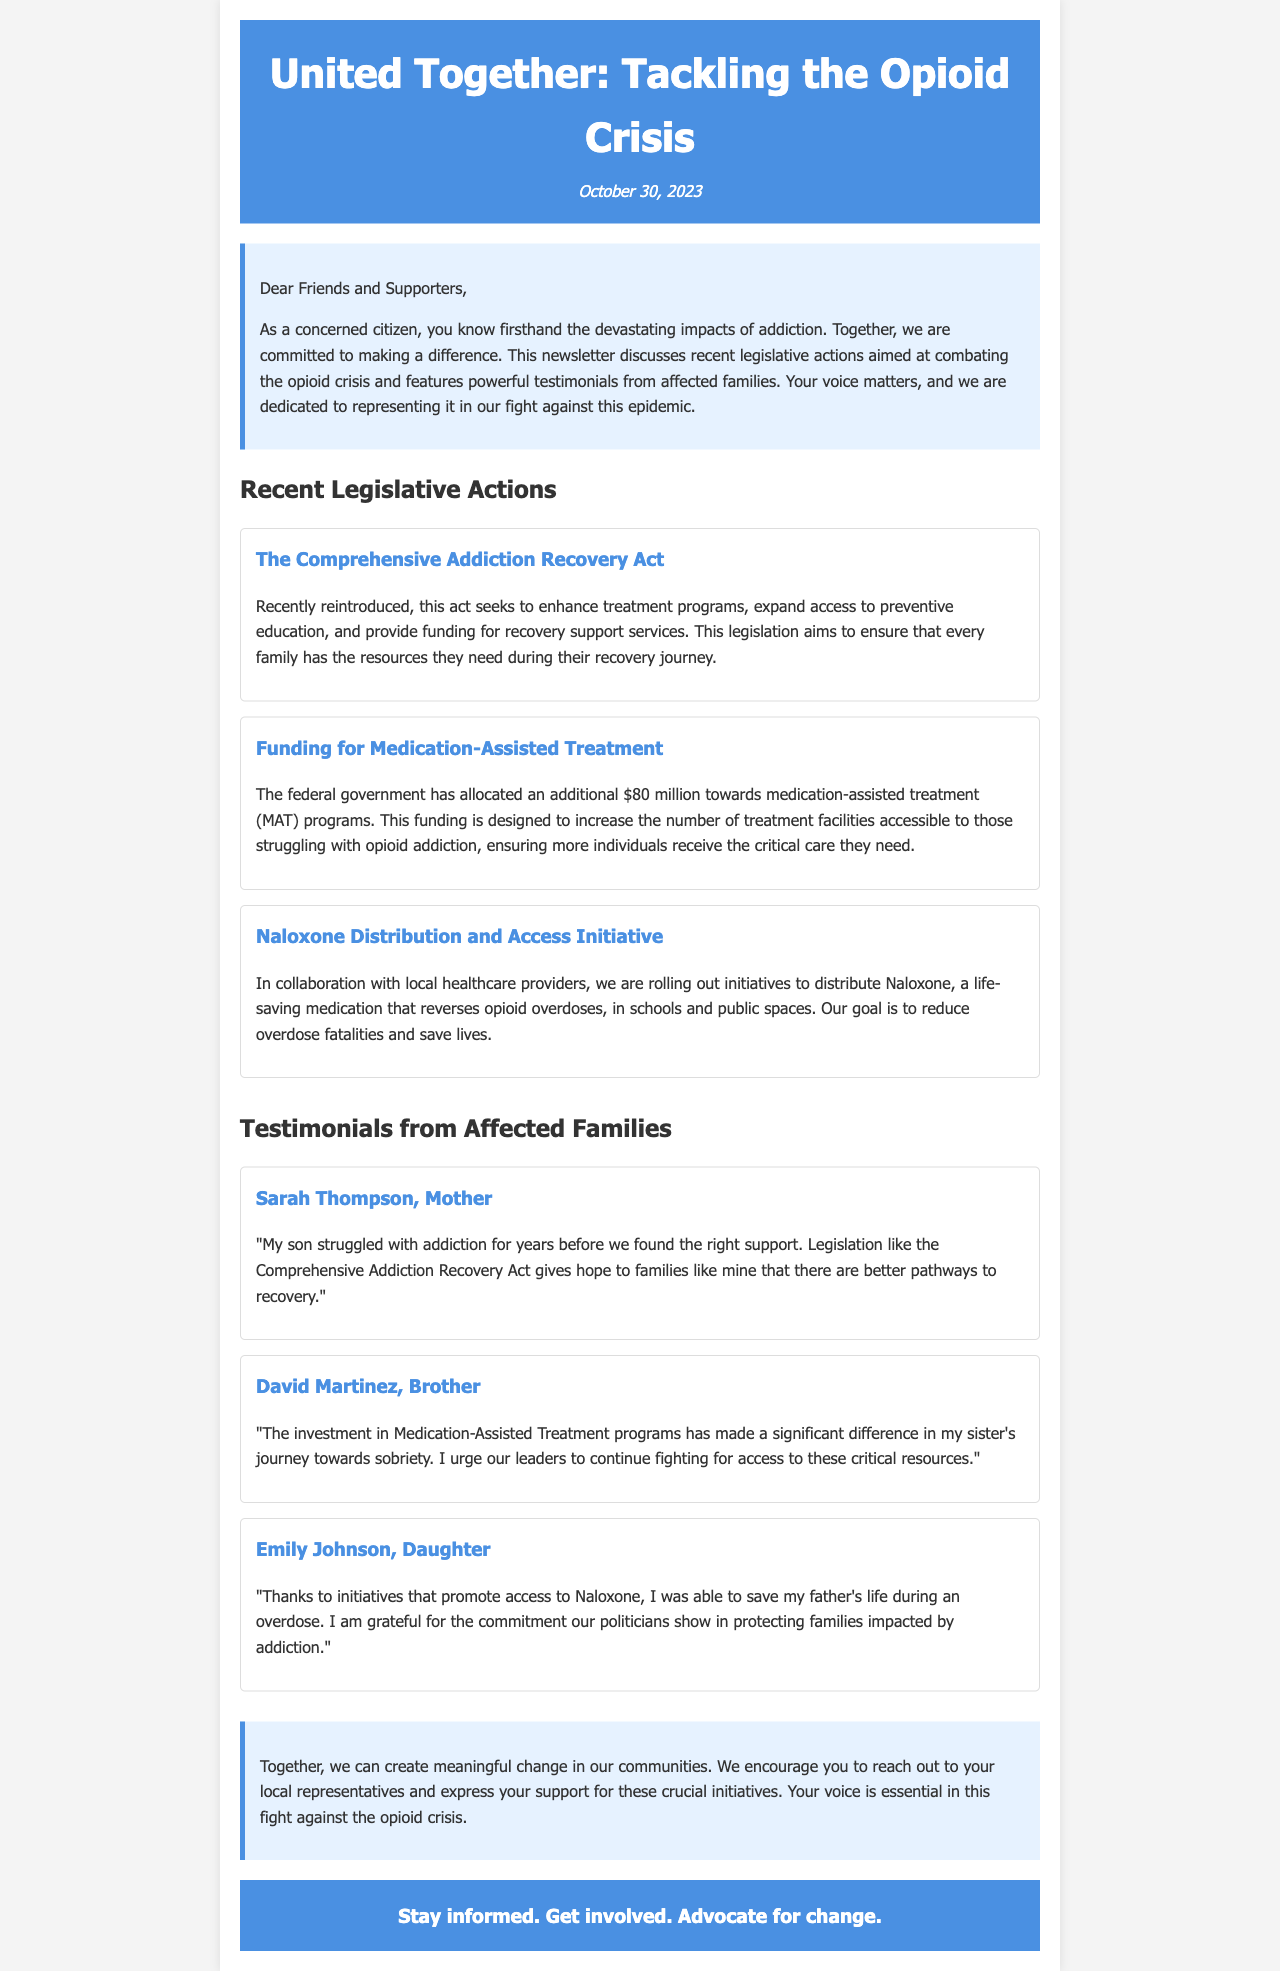What is the title of the newsletter? The title of the newsletter is prominently displayed at the top of the document, which is "United Together: Tackling the Opioid Crisis."
Answer: United Together: Tackling the Opioid Crisis When was the newsletter published? The publication date is shown in the header of the document, which states "October 30, 2023."
Answer: October 30, 2023 What is the funding amount allocated for Medication-Assisted Treatment? The document specifies the funding amount for MAT programs as "$80 million."
Answer: $80 million Which act is aimed at enhancing treatment programs? The document mentions "The Comprehensive Addiction Recovery Act" as the act focused on enhancing treatment programs.
Answer: The Comprehensive Addiction Recovery Act Who expressed gratitude for the Naloxone initiatives? The document presents a testimonial from "Emily Johnson, Daughter," who expresses gratitude for initiatives that promote access to Naloxone.
Answer: Emily Johnson What is the main goal of the Naloxone Distribution Initiative? The document states that the goal is to "reduce overdose fatalities and save lives."
Answer: Reduce overdose fatalities and save lives What type of feedback does the newsletter encourage from its readers? The conclusion of the document encourages readers to "reach out to your local representatives" to express support for initiatives.
Answer: Reach out to your local representatives How many testimonials are included from affected families? The document includes three testimonials from affected families as part of the newsletter's content.
Answer: Three 